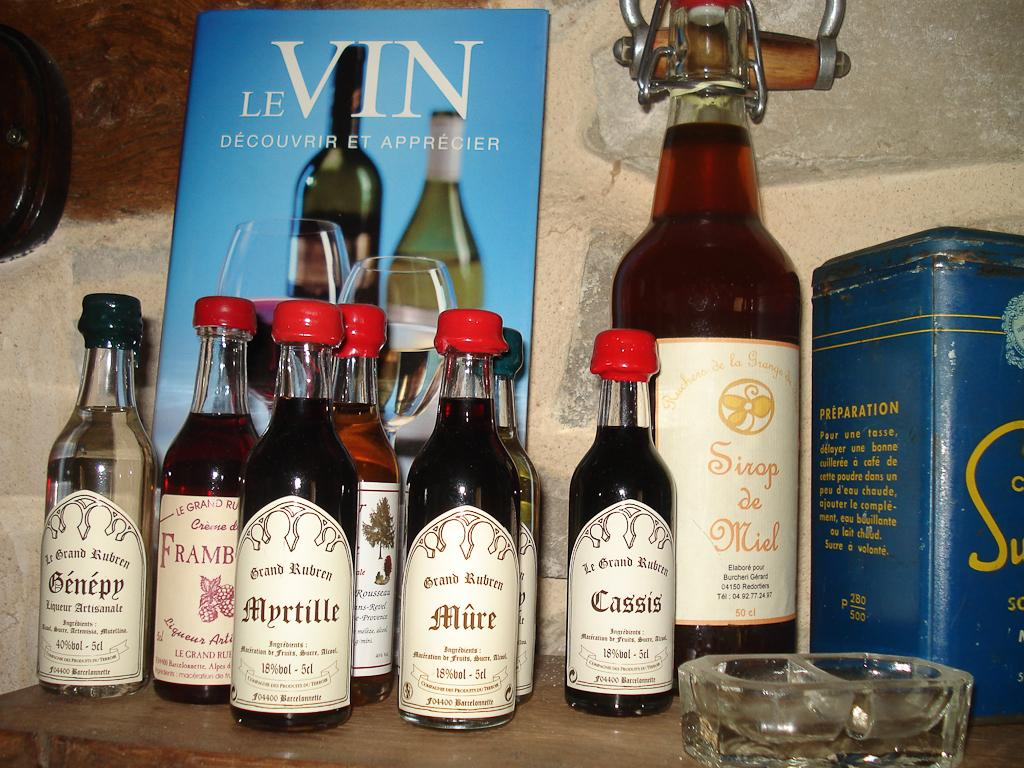<image>
Present a compact description of the photo's key features. Different kinds of liquor from Le Grand Ruben are displayed infront of a brochure titled Le Vin. 